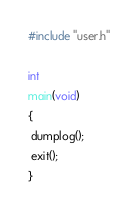Convert code to text. <code><loc_0><loc_0><loc_500><loc_500><_C_>#include "user.h"

int
main(void)
{
 dumplog();
 exit();
}</code> 